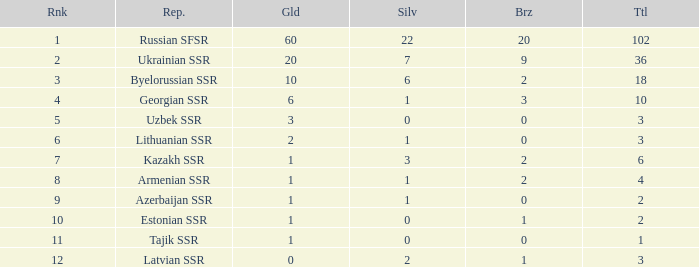What is the average total for teams with more than 1 gold, ranked over 3 and more than 3 bronze? None. 